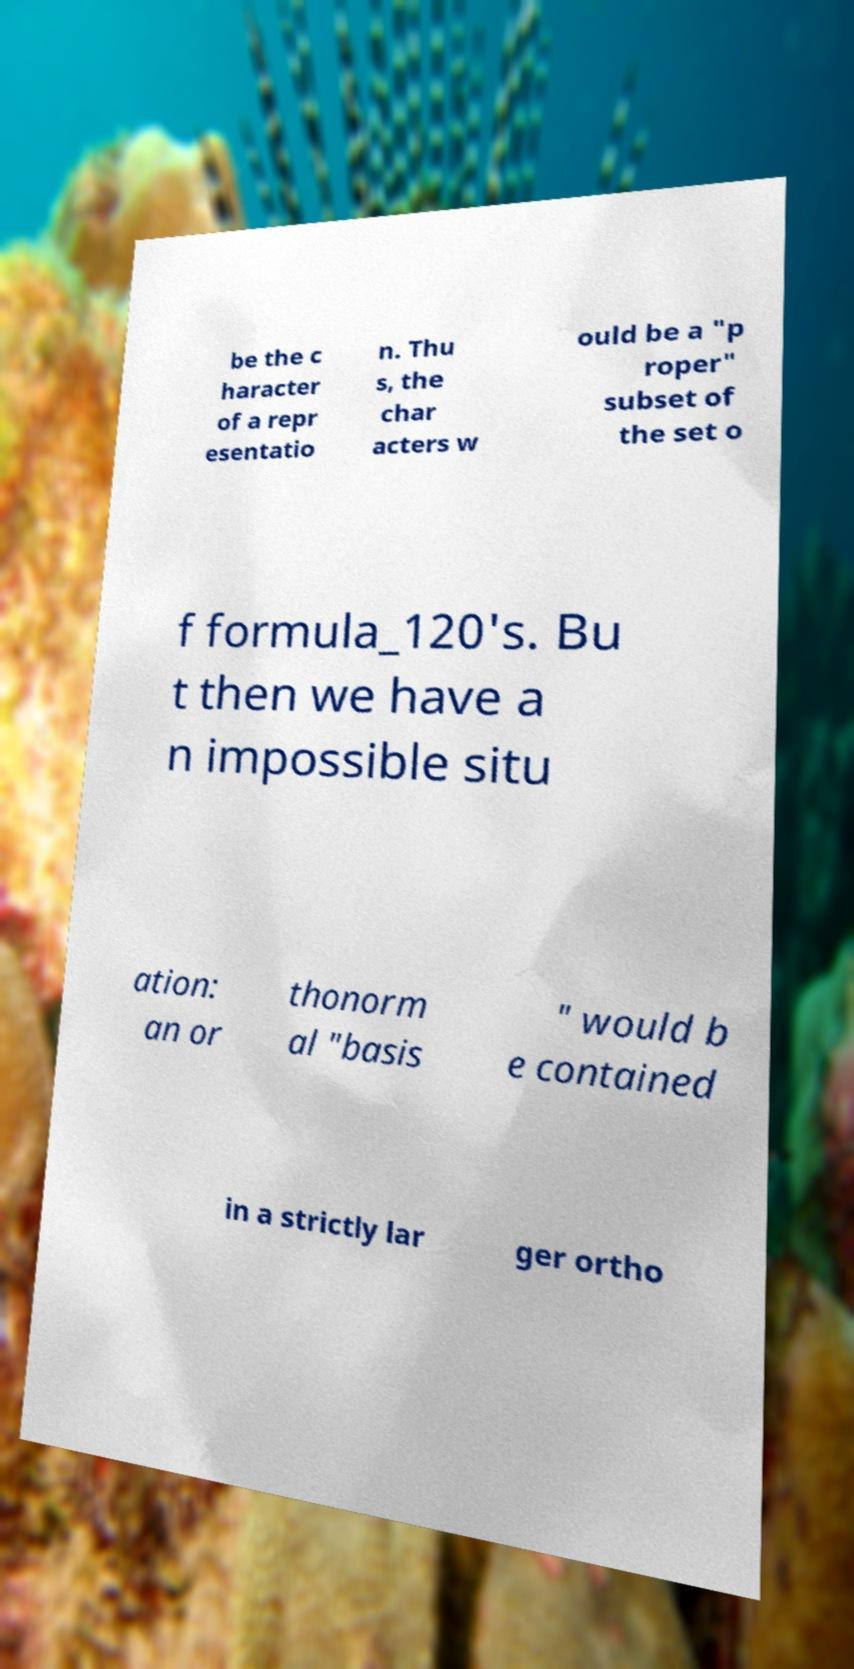Can you read and provide the text displayed in the image?This photo seems to have some interesting text. Can you extract and type it out for me? be the c haracter of a repr esentatio n. Thu s, the char acters w ould be a "p roper" subset of the set o f formula_120's. Bu t then we have a n impossible situ ation: an or thonorm al "basis " would b e contained in a strictly lar ger ortho 